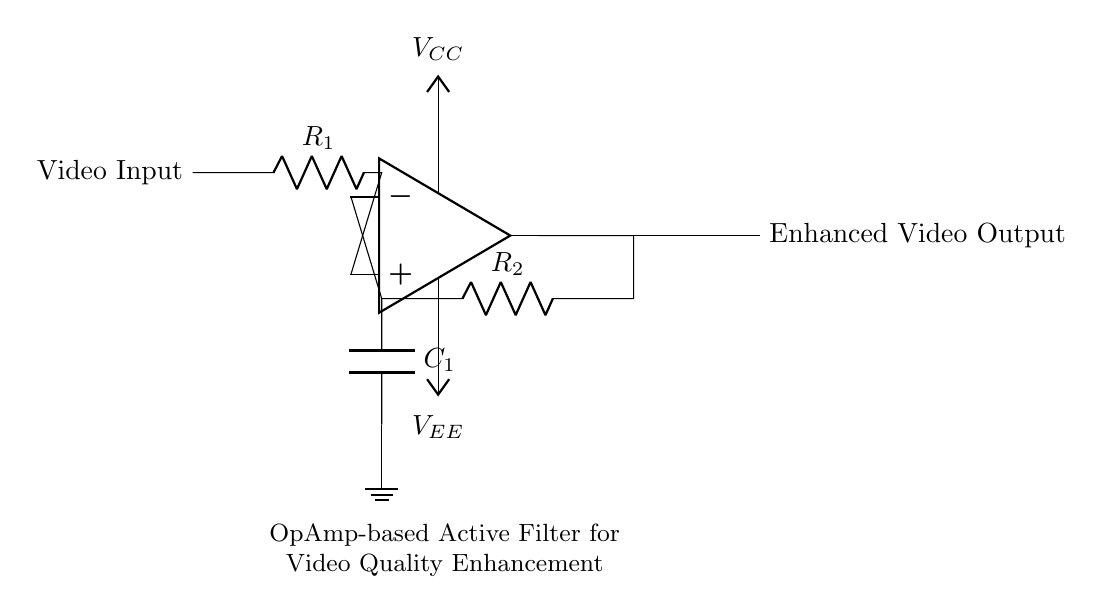What is the input component connected to the OpAmp? The input component is a resistor labeled R1, which is connected to the positive input of the OpAmp.
Answer: R1 What are the power supply voltages for the OpAmp? The circuit shows two power supply connections: VCC for positive voltage and VEE for negative voltage. These provide the necessary power for the OpAmp to function.
Answer: VCC and VEE What type of filter does this circuit implement? Given that this is an active filter circuit with an operational amplifier configuration, it is designed as a low-pass filter for video signals, enhancing quality by allowing lower frequency components to pass.
Answer: Low-pass filter What is the role of the capacitor C1 in the circuit? The capacitor C1 works in conjunction with the resistor R2 to set the cutoff frequency of the low-pass filter, allowing specific frequencies to be filtered out and enhancing overall video quality.
Answer: Cutoff frequency What is the output of the circuit labeled as? The output of the OpAmp in this circuit is labeled as "Enhanced Video Output," indicating that the circuit is designed to improve the quality of the video signal for teleconferencing systems.
Answer: Enhanced Video Output Why is the video input connected to the positive terminal of the OpAmp? The video input is connected primarily to amplify the incoming signal. Connecting it to the positive terminal allows the OpAmp to increase the signal strength while filtering out unwanted frequencies.
Answer: To amplify the signal 